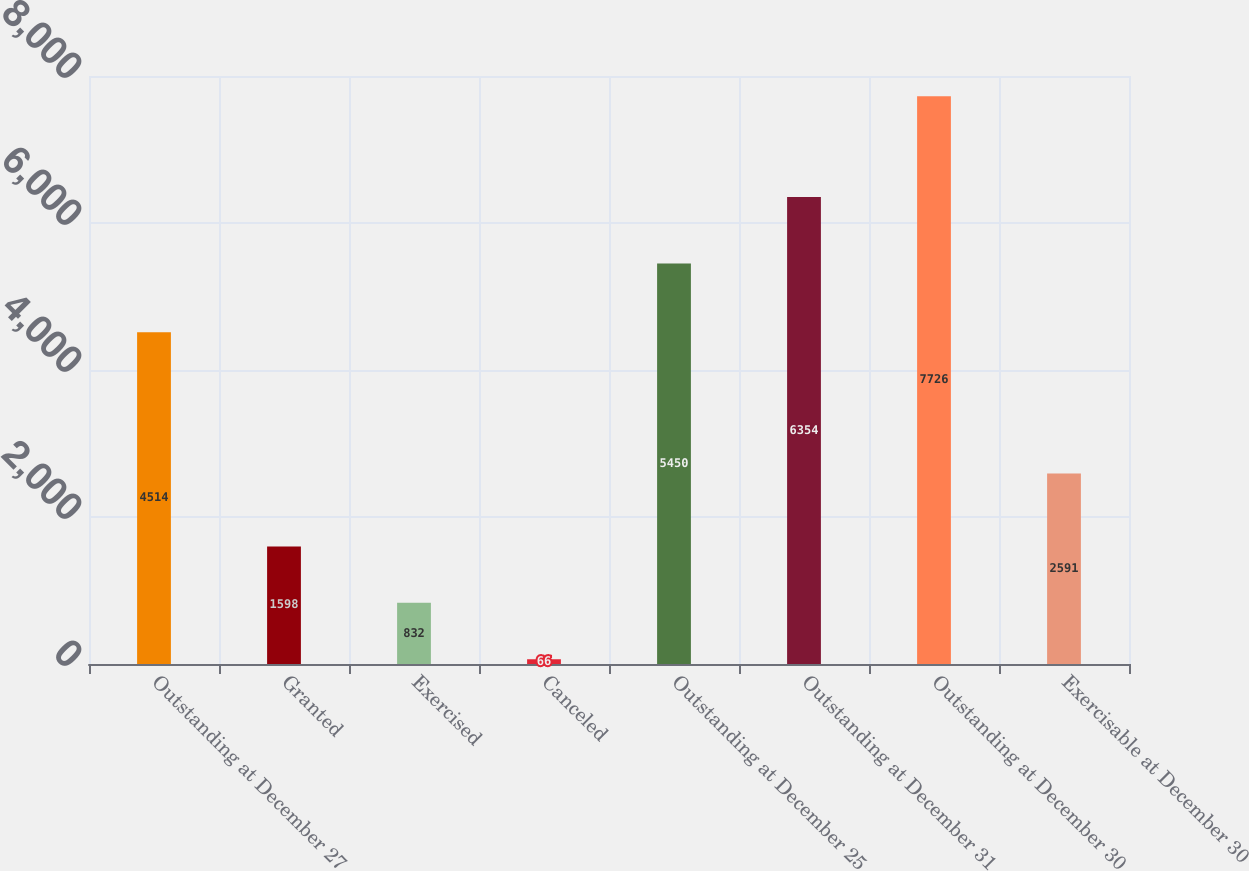<chart> <loc_0><loc_0><loc_500><loc_500><bar_chart><fcel>Outstanding at December 27<fcel>Granted<fcel>Exercised<fcel>Canceled<fcel>Outstanding at December 25<fcel>Outstanding at December 31<fcel>Outstanding at December 30<fcel>Exercisable at December 30<nl><fcel>4514<fcel>1598<fcel>832<fcel>66<fcel>5450<fcel>6354<fcel>7726<fcel>2591<nl></chart> 